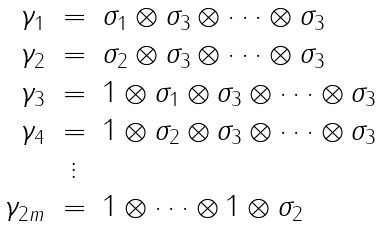<formula> <loc_0><loc_0><loc_500><loc_500>\begin{array} { r c l } \gamma _ { 1 } & = & \sigma _ { 1 } \otimes \sigma _ { 3 } \otimes \dots \otimes \sigma _ { 3 } \\ \gamma _ { 2 } & = & \sigma _ { 2 } \otimes \sigma _ { 3 } \otimes \dots \otimes \sigma _ { 3 } \\ \gamma _ { 3 } & = & 1 \otimes \sigma _ { 1 } \otimes \sigma _ { 3 } \otimes \dots \otimes \sigma _ { 3 } \\ \gamma _ { 4 } & = & 1 \otimes \sigma _ { 2 } \otimes \sigma _ { 3 } \otimes \dots \otimes \sigma _ { 3 } \\ & \vdots & \\ \gamma _ { 2 m } & = & 1 \otimes \dots \otimes 1 \otimes \sigma _ { 2 } \\ \end{array}</formula> 